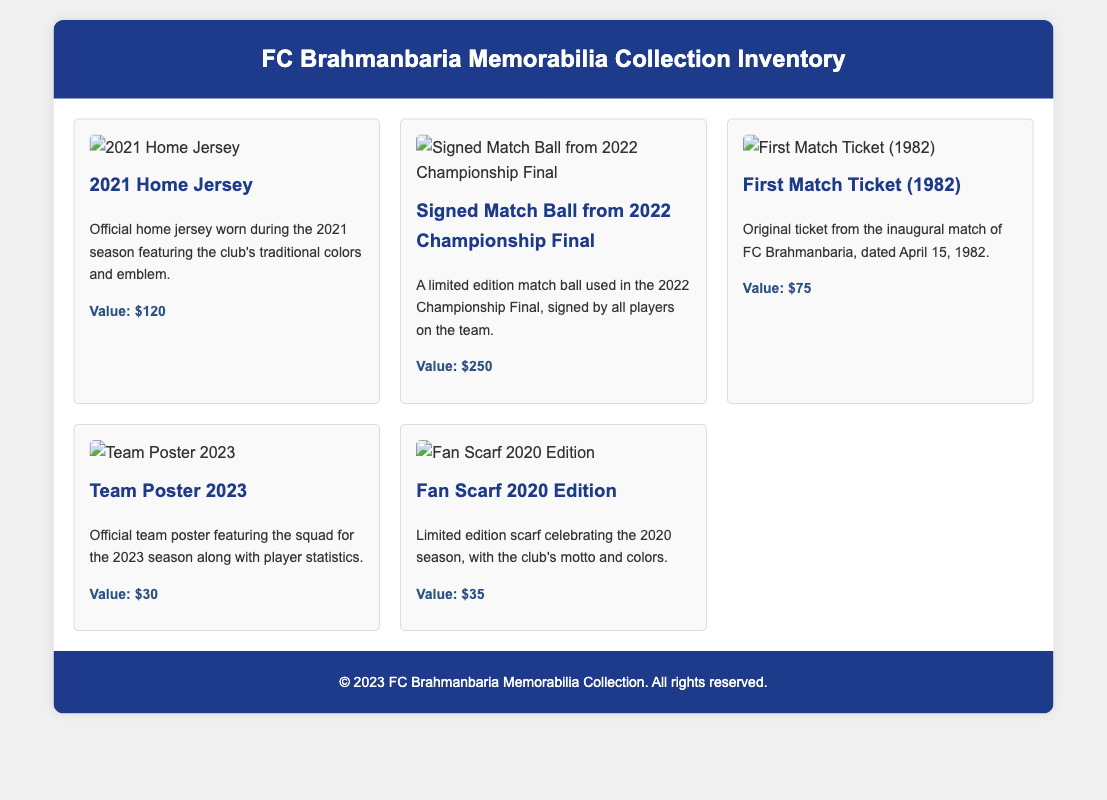What is the value of the 2021 Home Jersey? The value of the 2021 Home Jersey is stated in the document as $120.
Answer: $120 Who signed the match ball from the 2022 Championship Final? The document indicates that the match ball is signed by all players on the team.
Answer: All players on the team What year was the original ticket from the inaugural match? The document specifies that the ticket is from April 15, 1982.
Answer: 1982 What is featured on the Team Poster 2023? The Team Poster 2023 features the squad for the 2023 season along with player statistics.
Answer: Squad and player statistics What is the value of the Fan Scarf 2020 Edition? The document mentions that the value of the Fan Scarf 2020 Edition is $35.
Answer: $35 Which item has a value of $250? According to the document, the Signed Match Ball from the 2022 Championship Final has a value of $250.
Answer: Signed Match Ball from 2022 Championship Final How many collectible items are listed in the document? The document lists a total of five collectible items related to FC Brahmanbaria.
Answer: Five What does the Fan Scarf 2020 Edition celebrate? The Fan Scarf 2020 Edition celebrates the 2020 season.
Answer: The 2020 season What type of memorabilia is the original ticket from? The original ticket is from the inaugural match of FC Brahmanbaria.
Answer: Inaugural match 